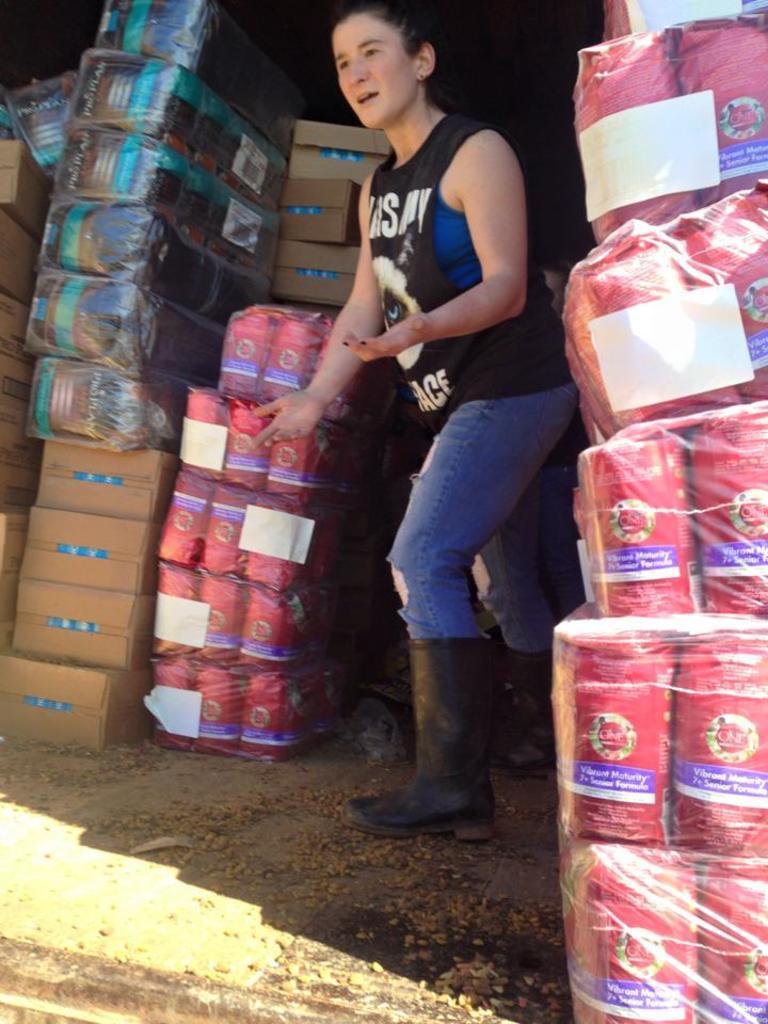Describe this image in one or two sentences. There is one woman standing in the middle of this image, and there are some bundles and boxes are present on the left side of this image and right side of this image as well. 